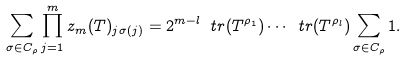<formula> <loc_0><loc_0><loc_500><loc_500>\sum _ { \sigma \in C _ { \rho } } \prod _ { j = 1 } ^ { m } z _ { m } ( T ) _ { j \sigma ( j ) } = 2 ^ { m - l } \ t r ( T ^ { \rho _ { 1 } } ) \cdots \ t r ( T ^ { \rho _ { l } } ) \sum _ { \sigma \in C _ { \rho } } 1 .</formula> 